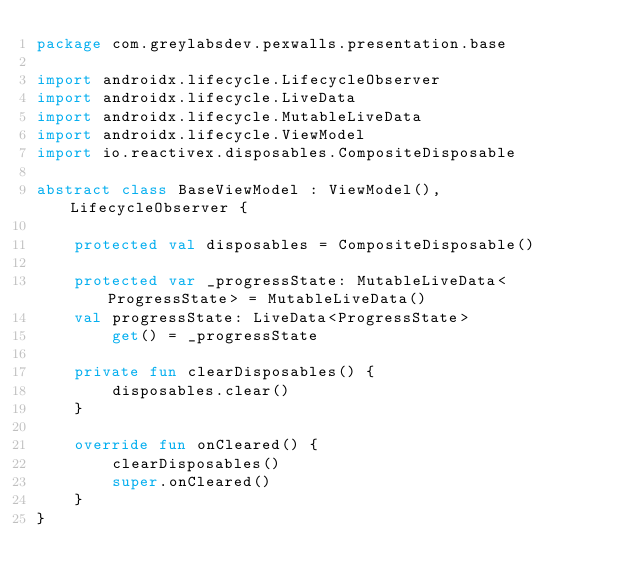<code> <loc_0><loc_0><loc_500><loc_500><_Kotlin_>package com.greylabsdev.pexwalls.presentation.base

import androidx.lifecycle.LifecycleObserver
import androidx.lifecycle.LiveData
import androidx.lifecycle.MutableLiveData
import androidx.lifecycle.ViewModel
import io.reactivex.disposables.CompositeDisposable

abstract class BaseViewModel : ViewModel(), LifecycleObserver {

    protected val disposables = CompositeDisposable()

    protected var _progressState: MutableLiveData<ProgressState> = MutableLiveData()
    val progressState: LiveData<ProgressState>
        get() = _progressState

    private fun clearDisposables() {
        disposables.clear()
    }

    override fun onCleared() {
        clearDisposables()
        super.onCleared()
    }
}
</code> 